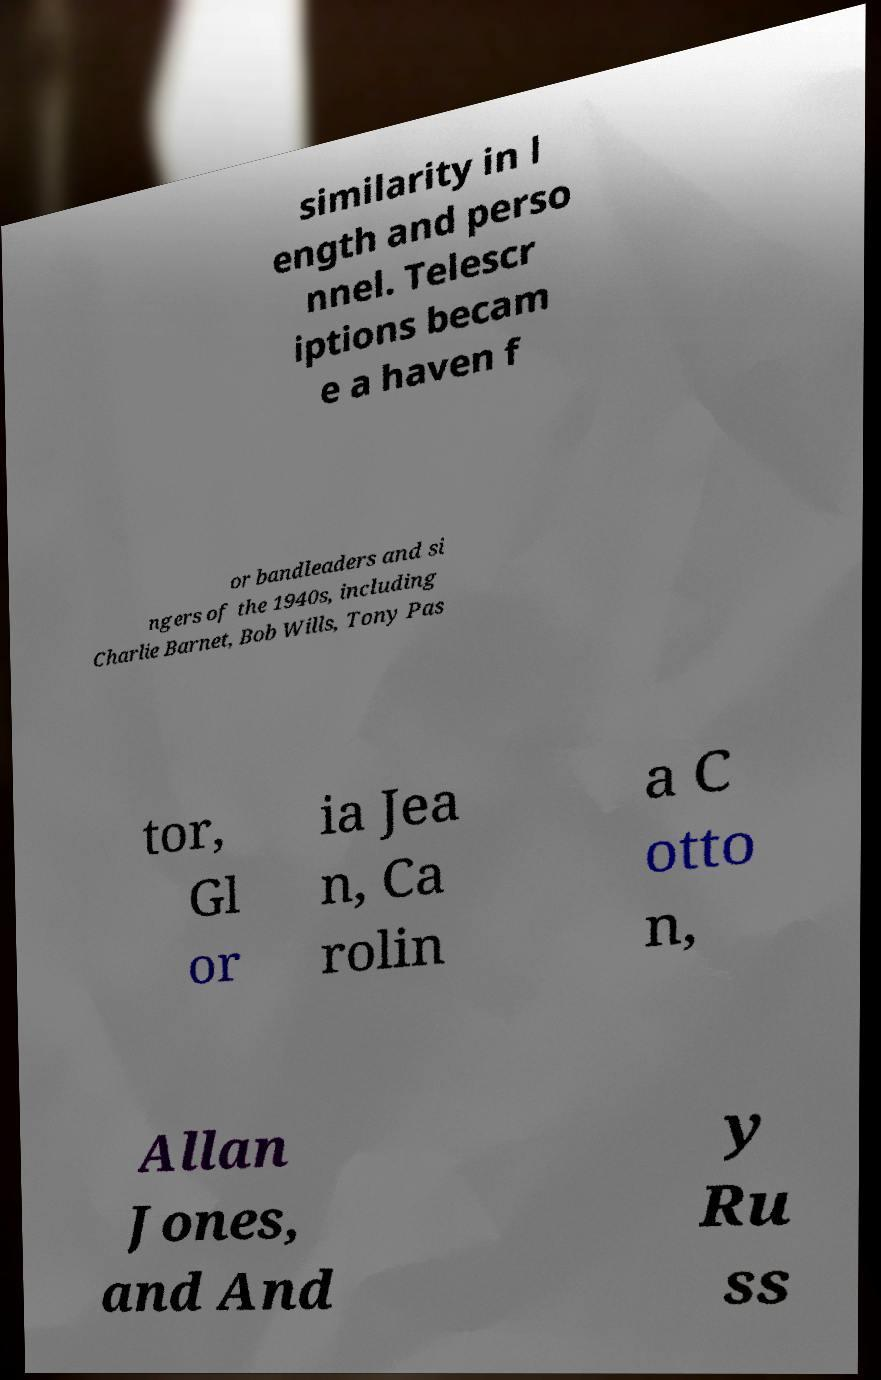I need the written content from this picture converted into text. Can you do that? similarity in l ength and perso nnel. Telescr iptions becam e a haven f or bandleaders and si ngers of the 1940s, including Charlie Barnet, Bob Wills, Tony Pas tor, Gl or ia Jea n, Ca rolin a C otto n, Allan Jones, and And y Ru ss 